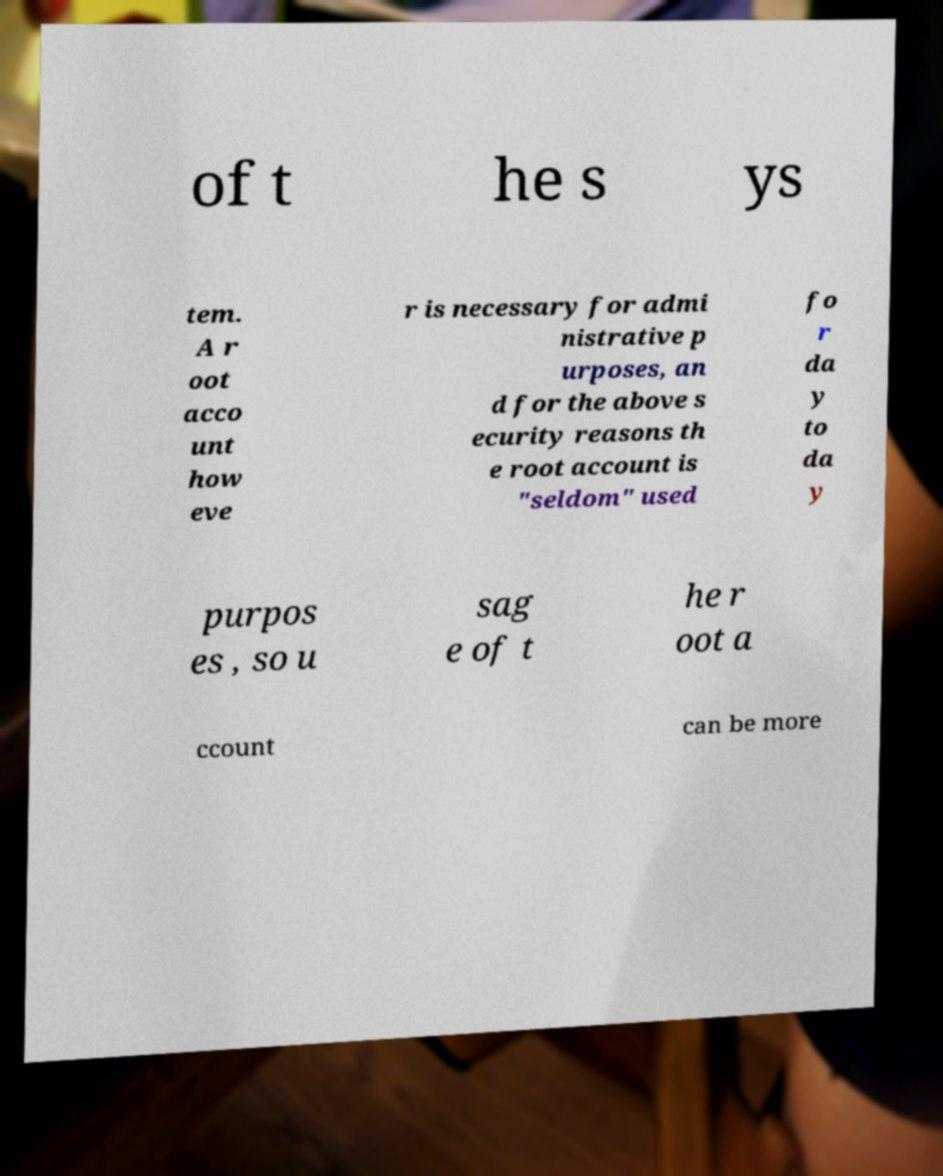For documentation purposes, I need the text within this image transcribed. Could you provide that? of t he s ys tem. A r oot acco unt how eve r is necessary for admi nistrative p urposes, an d for the above s ecurity reasons th e root account is "seldom" used fo r da y to da y purpos es , so u sag e of t he r oot a ccount can be more 